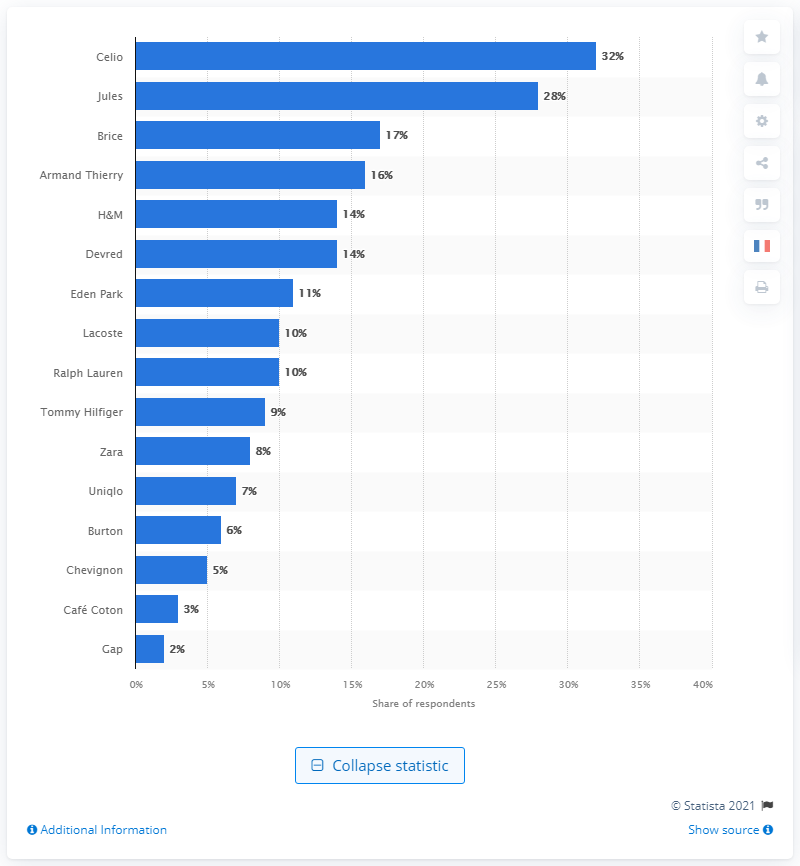Identify some key points in this picture. The second favorite ready-to-wear brand was Jules. The most popular men's fashion brand was Celio. 